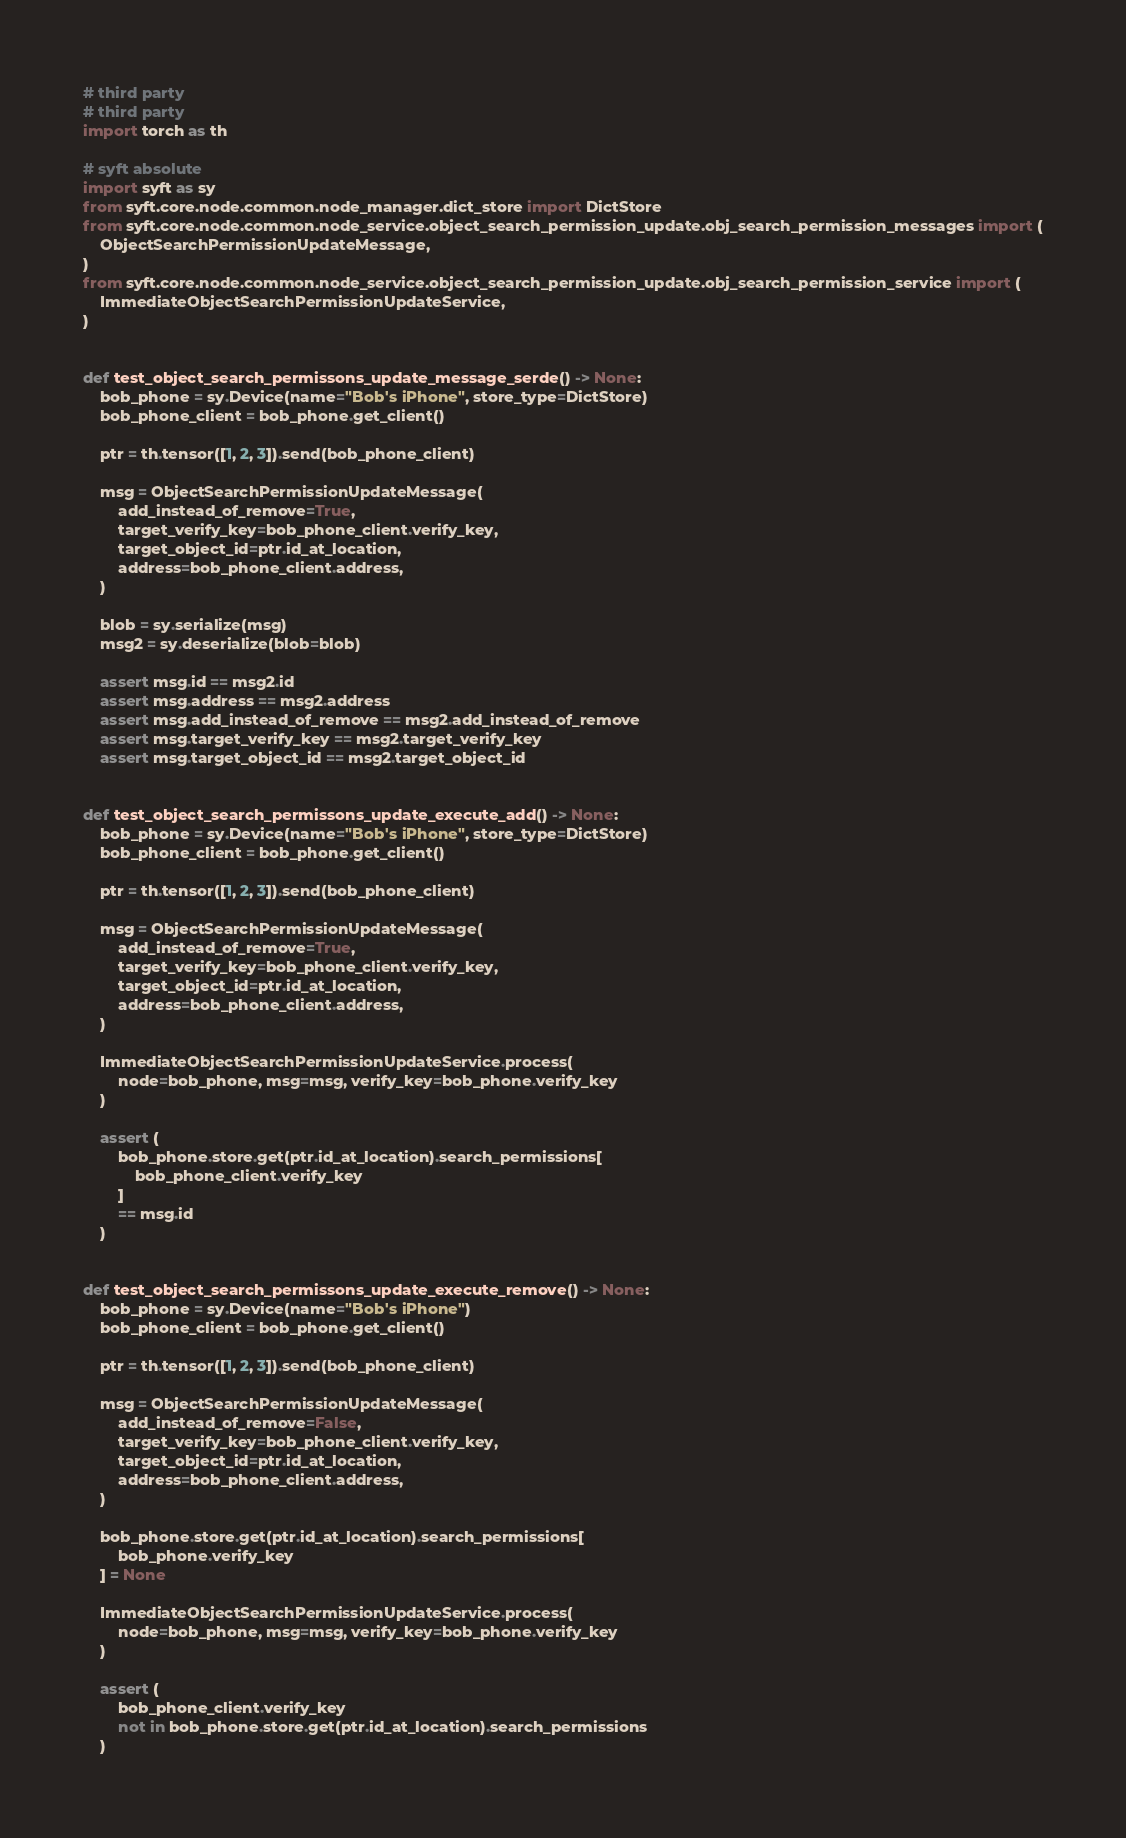<code> <loc_0><loc_0><loc_500><loc_500><_Python_># third party
# third party
import torch as th

# syft absolute
import syft as sy
from syft.core.node.common.node_manager.dict_store import DictStore
from syft.core.node.common.node_service.object_search_permission_update.obj_search_permission_messages import (
    ObjectSearchPermissionUpdateMessage,
)
from syft.core.node.common.node_service.object_search_permission_update.obj_search_permission_service import (
    ImmediateObjectSearchPermissionUpdateService,
)


def test_object_search_permissons_update_message_serde() -> None:
    bob_phone = sy.Device(name="Bob's iPhone", store_type=DictStore)
    bob_phone_client = bob_phone.get_client()

    ptr = th.tensor([1, 2, 3]).send(bob_phone_client)

    msg = ObjectSearchPermissionUpdateMessage(
        add_instead_of_remove=True,
        target_verify_key=bob_phone_client.verify_key,
        target_object_id=ptr.id_at_location,
        address=bob_phone_client.address,
    )

    blob = sy.serialize(msg)
    msg2 = sy.deserialize(blob=blob)

    assert msg.id == msg2.id
    assert msg.address == msg2.address
    assert msg.add_instead_of_remove == msg2.add_instead_of_remove
    assert msg.target_verify_key == msg2.target_verify_key
    assert msg.target_object_id == msg2.target_object_id


def test_object_search_permissons_update_execute_add() -> None:
    bob_phone = sy.Device(name="Bob's iPhone", store_type=DictStore)
    bob_phone_client = bob_phone.get_client()

    ptr = th.tensor([1, 2, 3]).send(bob_phone_client)

    msg = ObjectSearchPermissionUpdateMessage(
        add_instead_of_remove=True,
        target_verify_key=bob_phone_client.verify_key,
        target_object_id=ptr.id_at_location,
        address=bob_phone_client.address,
    )

    ImmediateObjectSearchPermissionUpdateService.process(
        node=bob_phone, msg=msg, verify_key=bob_phone.verify_key
    )

    assert (
        bob_phone.store.get(ptr.id_at_location).search_permissions[
            bob_phone_client.verify_key
        ]
        == msg.id
    )


def test_object_search_permissons_update_execute_remove() -> None:
    bob_phone = sy.Device(name="Bob's iPhone")
    bob_phone_client = bob_phone.get_client()

    ptr = th.tensor([1, 2, 3]).send(bob_phone_client)

    msg = ObjectSearchPermissionUpdateMessage(
        add_instead_of_remove=False,
        target_verify_key=bob_phone_client.verify_key,
        target_object_id=ptr.id_at_location,
        address=bob_phone_client.address,
    )

    bob_phone.store.get(ptr.id_at_location).search_permissions[
        bob_phone.verify_key
    ] = None

    ImmediateObjectSearchPermissionUpdateService.process(
        node=bob_phone, msg=msg, verify_key=bob_phone.verify_key
    )

    assert (
        bob_phone_client.verify_key
        not in bob_phone.store.get(ptr.id_at_location).search_permissions
    )
</code> 